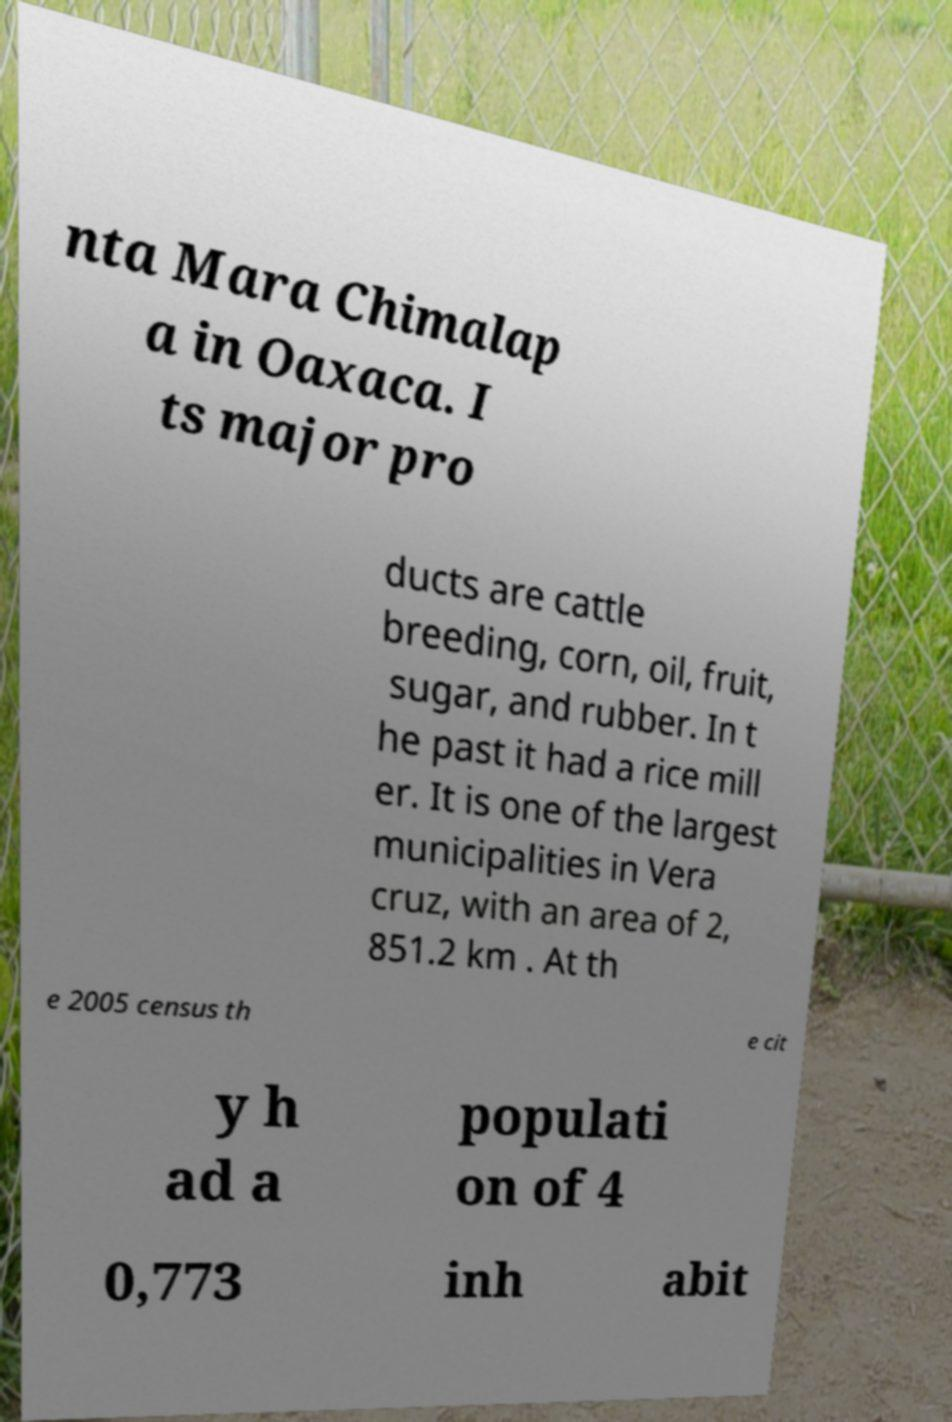Can you accurately transcribe the text from the provided image for me? nta Mara Chimalap a in Oaxaca. I ts major pro ducts are cattle breeding, corn, oil, fruit, sugar, and rubber. In t he past it had a rice mill er. It is one of the largest municipalities in Vera cruz, with an area of 2, 851.2 km . At th e 2005 census th e cit y h ad a populati on of 4 0,773 inh abit 